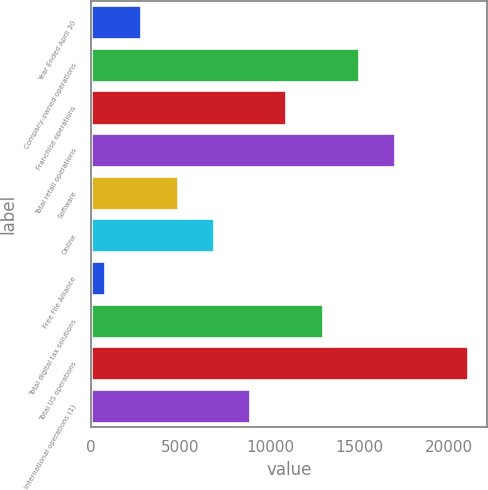Convert chart to OTSL. <chart><loc_0><loc_0><loc_500><loc_500><bar_chart><fcel>Year Ended April 30<fcel>Company-owned operations<fcel>Franchise operations<fcel>Total retail operations<fcel>Software<fcel>Online<fcel>Free File Alliance<fcel>Total digital tax solutions<fcel>Total US operations<fcel>International operations (1)<nl><fcel>2813.1<fcel>14963.7<fcel>10913.5<fcel>16988.8<fcel>4838.2<fcel>6863.3<fcel>788<fcel>12938.6<fcel>21039<fcel>8888.4<nl></chart> 